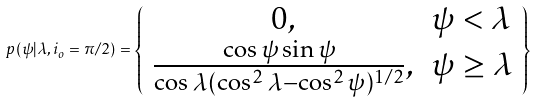<formula> <loc_0><loc_0><loc_500><loc_500>p ( \psi | \lambda , i _ { o } = \pi / 2 ) = \left \{ \begin{array} { c l } 0 , & \psi < \lambda \\ \frac { \cos \psi \sin \psi } { \cos \lambda ( \cos ^ { 2 } \lambda - \cos ^ { 2 } \psi ) ^ { 1 / 2 } } , & \psi \geq \lambda \end{array} \right \}</formula> 